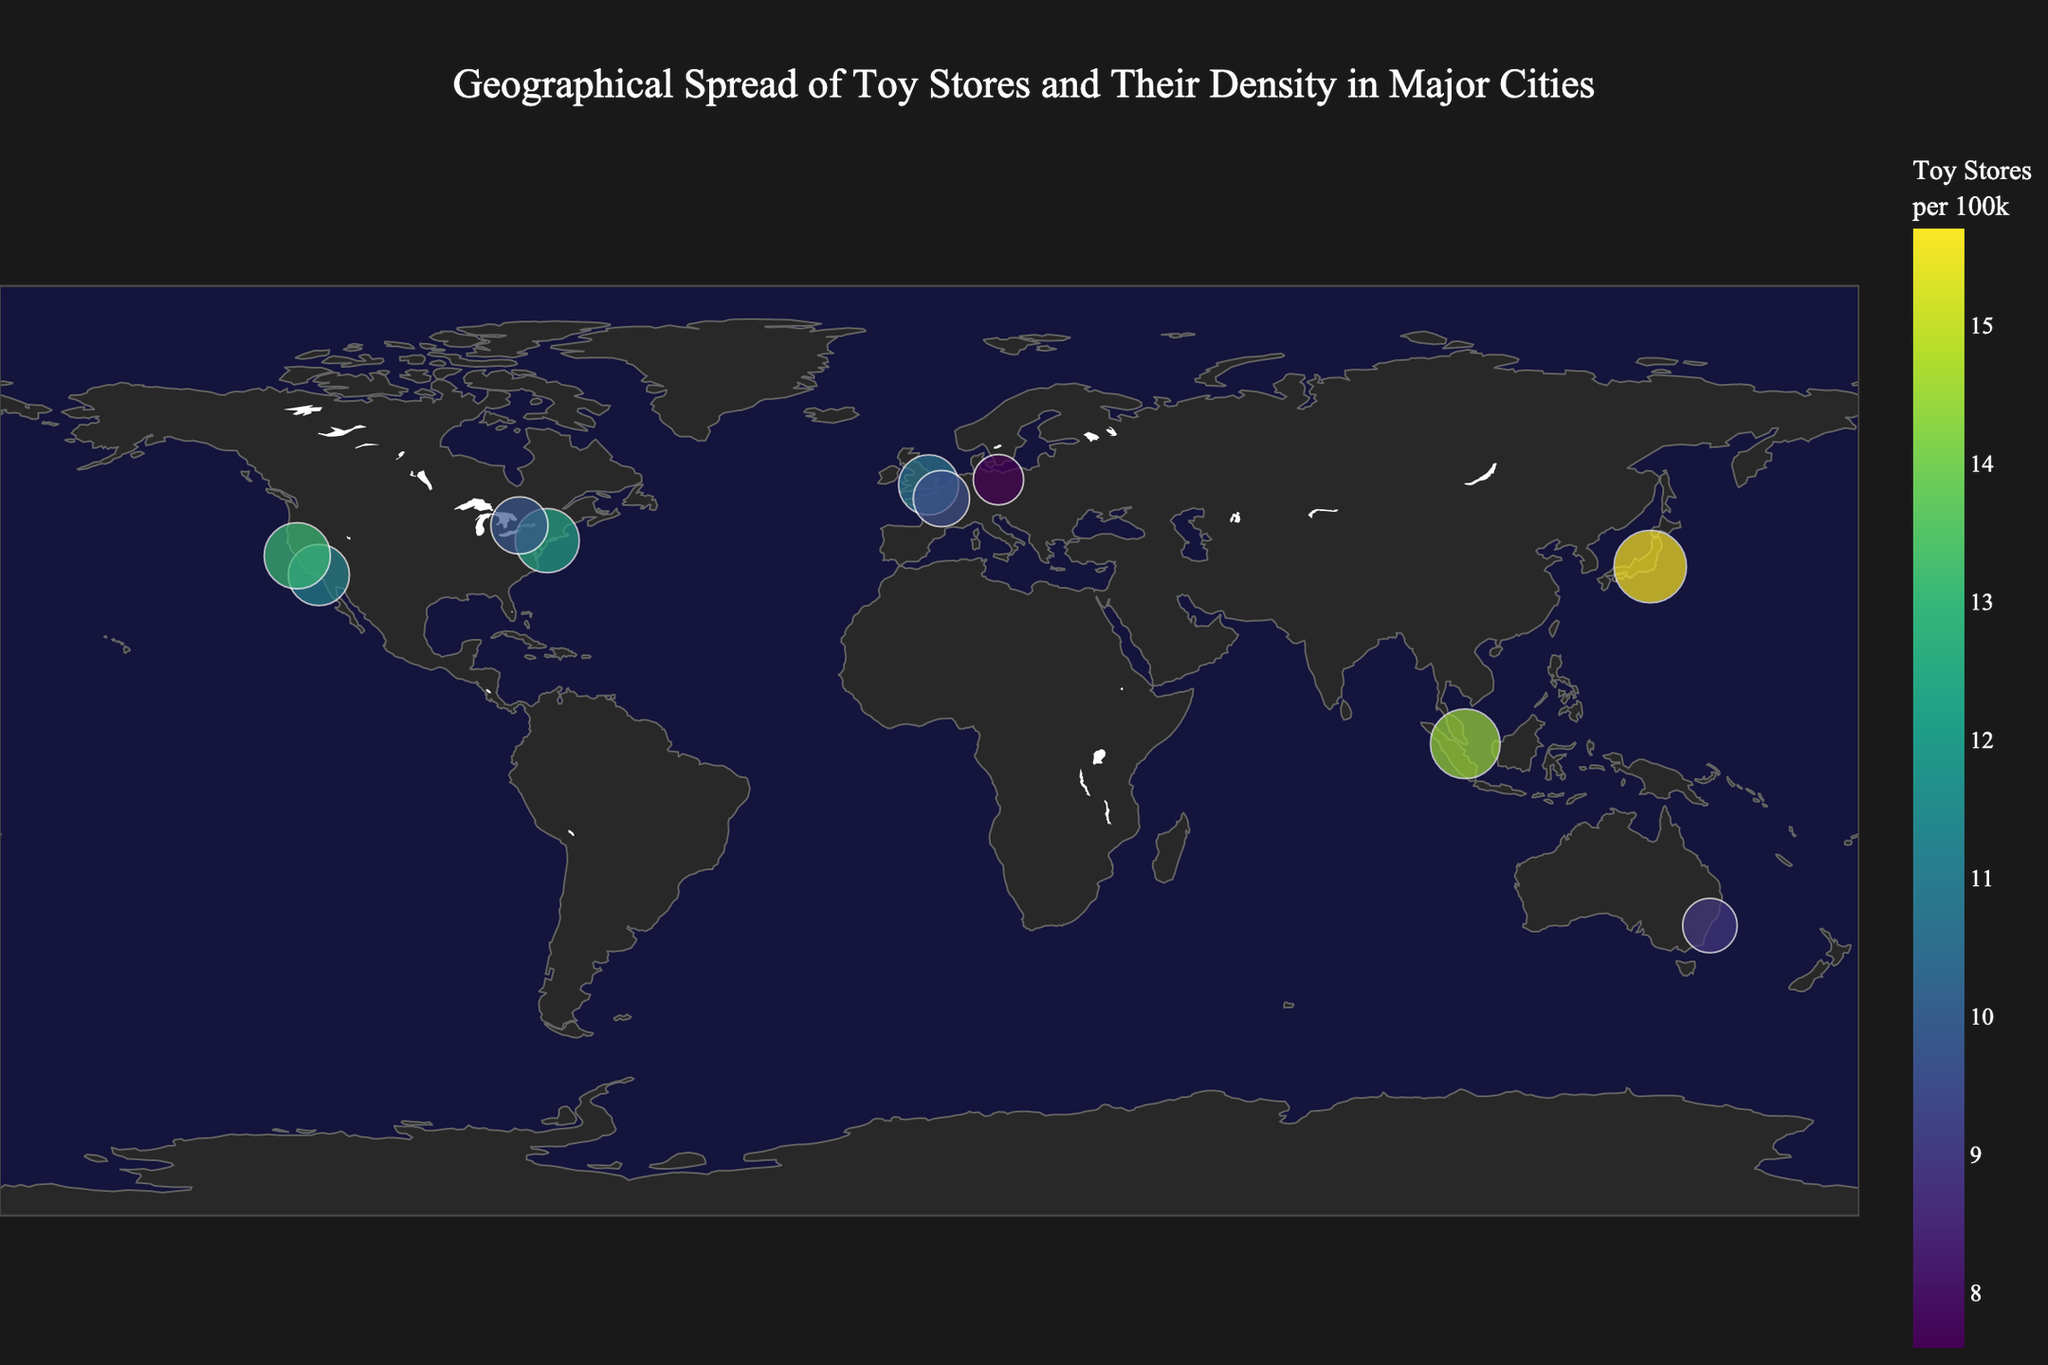How many cities are represented on the map? There are points representing major cities on the map. By counting the data points, we see that there are 10 cities represented.
Answer: 10 Which city has the highest density of toy stores per 100k people? The color intensity and size of the points indicate the density of toy stores per 100k people. Tokyo is the city with the largest marker and darkest color, showing the highest density at 15.7 toy stores per 100k people.
Answer: Tokyo What is the top-selling toy in Sydney? By hovering over Sydney on the map, the tooltip displays the top-selling toy as "Star Trek Phaser Toy."
Answer: Star Trek Phaser Toy Which city has the lowest density of toy stores per 100k people? The point with the smallest size and lightest color represents the lowest density. Berlin, with a density of 7.6 toy stores per 100k people, is the lowest.
Answer: Berlin Compare the density of toy stores between New York City and Toronto. Which city has a higher density? By comparing the sizes and colors, New York City has a density of 12.3 toy stores per 100k, while Toronto has 9.8. New York City has a higher density.
Answer: New York City Which continents have cities represented on the map? Observing the locations of the data points on the world map: North America (New York City, Los Angeles, San Francisco, Toronto), Asia (Tokyo, Singapore), Europe (London, Paris, Berlin), and Australia (Sydney) are represented.
Answer: North America, Asia, Europe, Australia What is the average density of toy stores per 100k people in the USA cities shown? In the USA, the cities are New York City (12.3), Los Angeles (11.2), and San Francisco (13.1). The average density is calculated by summing these and dividing by the number of cities: (12.3 + 11.2 + 13.1) / 3 = 12.2.
Answer: 12.2 Which city in Europe has the highest density of toy stores per 100k people, and what is the density? By comparing European cities (London, Paris, Berlin), London has the highest density at 10.8 toy stores per 100k people.
Answer: London, 10.8 Identify the city with the top-selling toy "Star Trek Communicator Badge." Hovering over Toronto on the map shows that the top-selling toy there is "Star Trek Communicator Badge."
Answer: Toronto How does the density of toy stores in San Francisco compare to Paris? By comparing the size and color, San Francisco has a density of 13.1 toy stores per 100k, while Paris has 9.5. San Francisco has a higher density than Paris.
Answer: San Francisco 